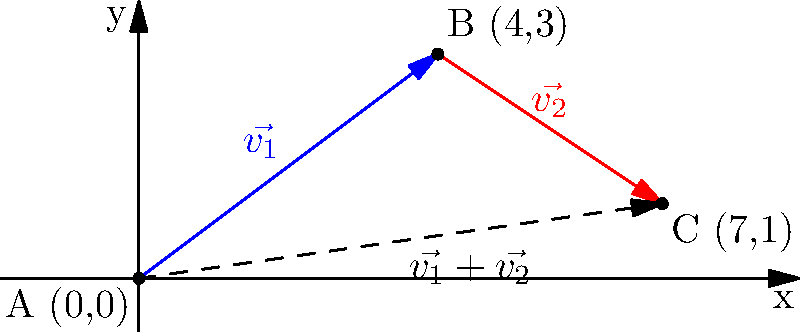In your innovative library layout, visitors need to navigate from the main entrance (point A) to the startup incubation area (point C) via the innovation hub (point B). The vector $\vec{v_1}$ represents the path from A to B, and $\vec{v_2}$ represents the path from B to C. Given that $\vec{v_1} = \langle 4, 3 \rangle$ and $\vec{v_2} = \langle 3, -2 \rangle$, what is the most efficient direct path from A to C in vector notation? To find the most efficient direct path from A to C, we need to add the vectors $\vec{v_1}$ and $\vec{v_2}$. This will give us the resultant vector that represents the direct path from A to C.

Step 1: Identify the given vectors
$\vec{v_1} = \langle 4, 3 \rangle$
$\vec{v_2} = \langle 3, -2 \rangle$

Step 2: Add the vectors component-wise
$\vec{v_1} + \vec{v_2} = \langle 4, 3 \rangle + \langle 3, -2 \rangle$
$= \langle 4+3, 3+(-2) \rangle$
$= \langle 7, 1 \rangle$

Step 3: Verify the result
The resultant vector $\langle 7, 1 \rangle$ indeed represents the direct path from A(0,0) to C(7,1) as shown in the diagram.

Therefore, the most efficient direct path from A to C is represented by the vector $\langle 7, 1 \rangle$.
Answer: $\langle 7, 1 \rangle$ 